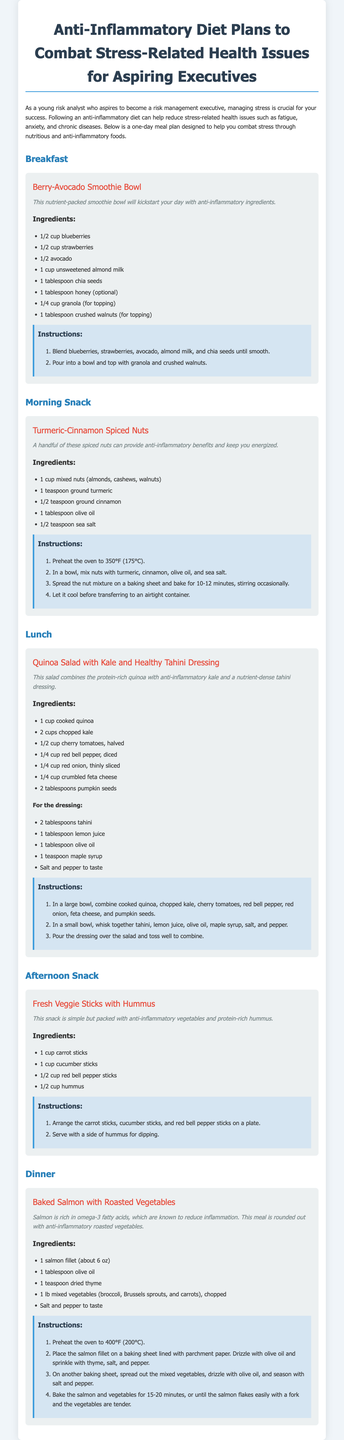What is the title of the meal plan? The title of the meal plan is presented at the top of the document.
Answer: Anti-Inflammatory Diet Plans to Combat Stress-Related Health Issues for Aspiring Executives What is the main benefit of following this diet? The main benefit is highlighted in the introductory paragraph focusing on managing stress and reducing health issues.
Answer: Reduce stress-related health issues What ingredients are used for the Berry-Avocado Smoothie Bowl? The ingredients list for the Berry-Avocado Smoothie Bowl is included under its meal section.
Answer: Blueberries, strawberries, avocado, almond milk, chia seeds, honey, granola, crushed walnuts How long should the Turmeric-Cinnamon Spiced Nuts bake in the oven? The baking time for the nuts is specified in the instructions section.
Answer: 10-12 minutes What type of fish is included in the dinner recipe? The type of fish is mentioned in the dinner section of the meal plan.
Answer: Salmon How many cups of chopped kale are used in the quinoa salad? The quantity of chopped kale for the salad is mentioned in the ingredients list of the lunch section.
Answer: 2 cups What are the main components of the dressing for the quinoa salad? The dressing ingredients are listed separately under the salad meal section.
Answer: Tahini, lemon juice, olive oil, maple syrup How many recipes are provided in total? The number of meal sections indicates the total recipes provided.
Answer: 5 recipes What color are the meal descriptions highlighted in? The highlighted color of the meal descriptions is noted throughout the meal plan.
Answer: Italic 